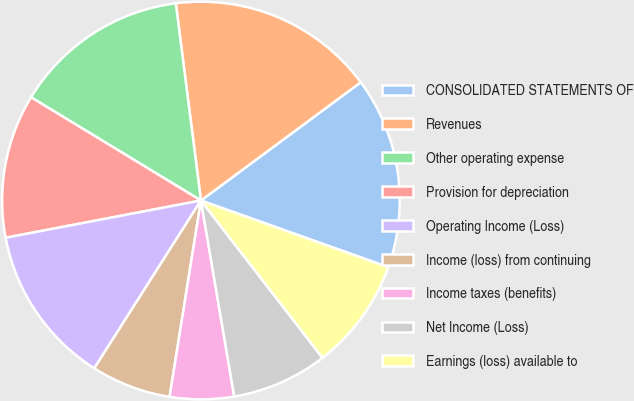Convert chart. <chart><loc_0><loc_0><loc_500><loc_500><pie_chart><fcel>CONSOLIDATED STATEMENTS OF<fcel>Revenues<fcel>Other operating expense<fcel>Provision for depreciation<fcel>Operating Income (Loss)<fcel>Income (loss) from continuing<fcel>Income taxes (benefits)<fcel>Net Income (Loss)<fcel>Earnings (loss) available to<nl><fcel>15.58%<fcel>16.88%<fcel>14.29%<fcel>11.69%<fcel>12.99%<fcel>6.49%<fcel>5.2%<fcel>7.79%<fcel>9.09%<nl></chart> 